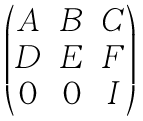Convert formula to latex. <formula><loc_0><loc_0><loc_500><loc_500>\begin{pmatrix} A & B & C \\ D & E & F \\ 0 & 0 & I \end{pmatrix}</formula> 